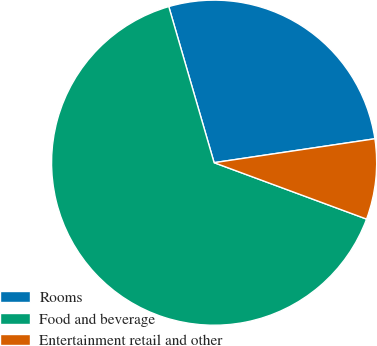<chart> <loc_0><loc_0><loc_500><loc_500><pie_chart><fcel>Rooms<fcel>Food and beverage<fcel>Entertainment retail and other<nl><fcel>27.15%<fcel>64.86%<fcel>7.99%<nl></chart> 